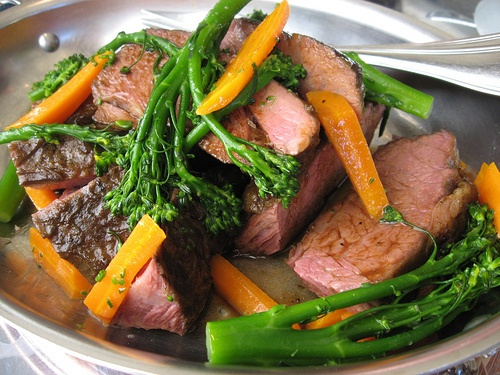Describe the objects in this image and their specific colors. I can see fork in lightgray, darkgray, and white tones, carrot in lightgray, orange, red, and tan tones, carrot in lightgray, orange, and gold tones, carrot in lightgray, orange, and gold tones, and broccoli in lightgray, green, darkgreen, and black tones in this image. 